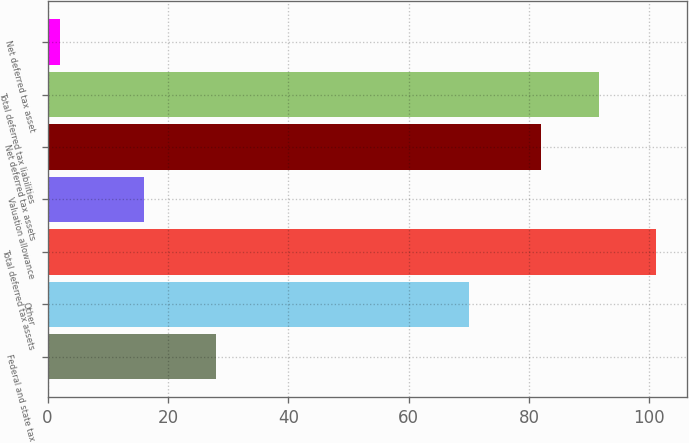<chart> <loc_0><loc_0><loc_500><loc_500><bar_chart><fcel>Federal and state tax<fcel>Other<fcel>Total deferred tax assets<fcel>Valuation allowance<fcel>Net deferred tax assets<fcel>Total deferred tax liabilities<fcel>Net deferred tax asset<nl><fcel>28<fcel>70<fcel>101.2<fcel>16<fcel>82<fcel>91.6<fcel>2<nl></chart> 